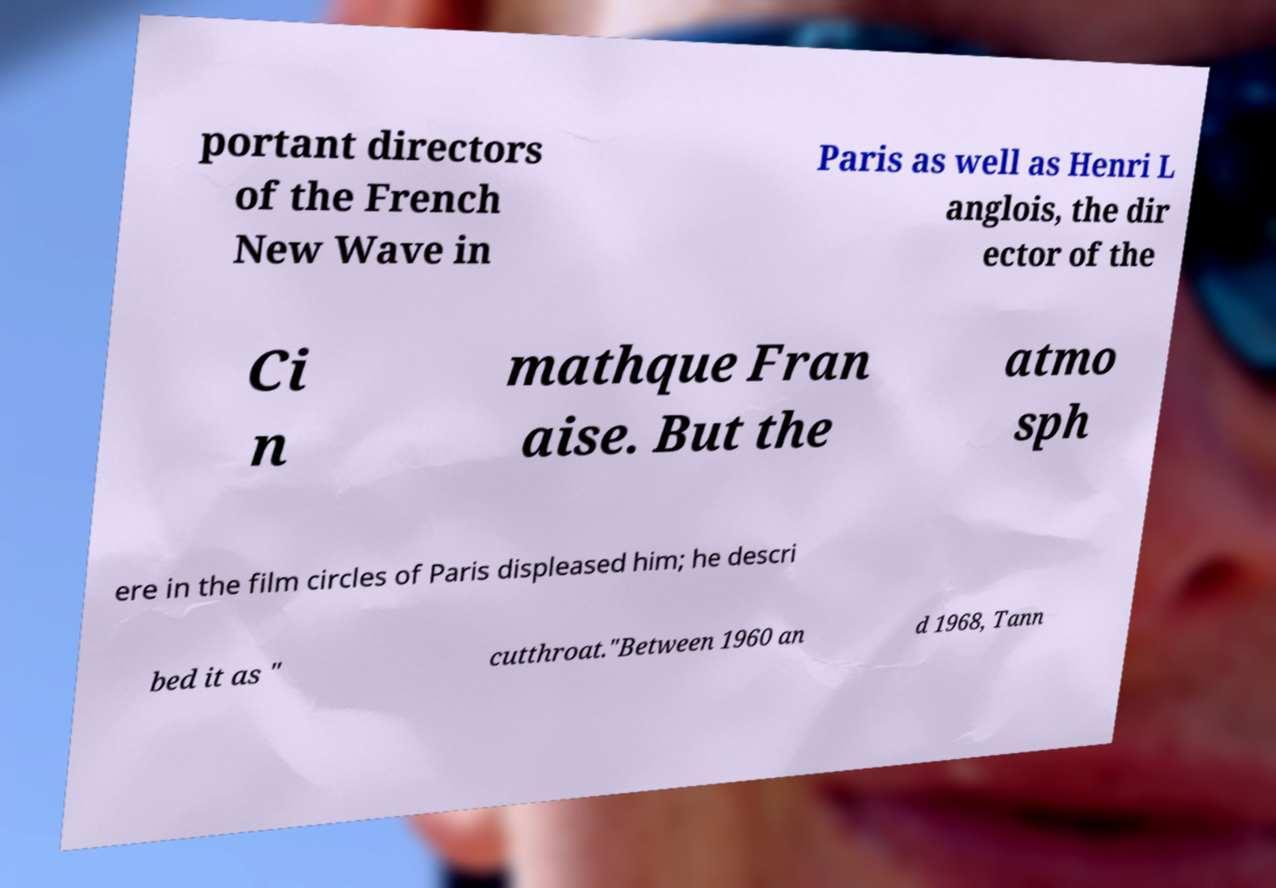What messages or text are displayed in this image? I need them in a readable, typed format. portant directors of the French New Wave in Paris as well as Henri L anglois, the dir ector of the Ci n mathque Fran aise. But the atmo sph ere in the film circles of Paris displeased him; he descri bed it as " cutthroat."Between 1960 an d 1968, Tann 